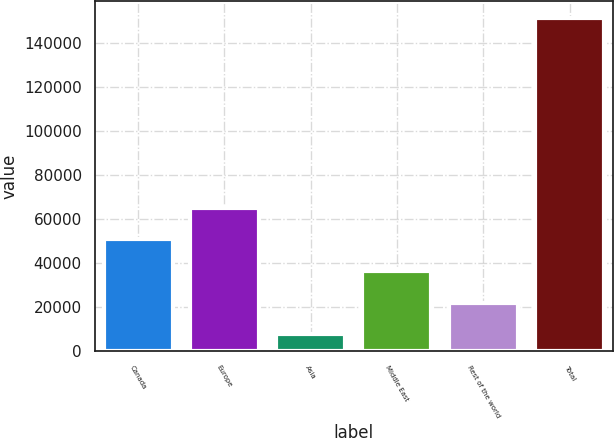<chart> <loc_0><loc_0><loc_500><loc_500><bar_chart><fcel>Canada<fcel>Europe<fcel>Asia<fcel>Middle East<fcel>Rest of the world<fcel>Total<nl><fcel>50669.5<fcel>65041<fcel>7555<fcel>36298<fcel>21926.5<fcel>151270<nl></chart> 